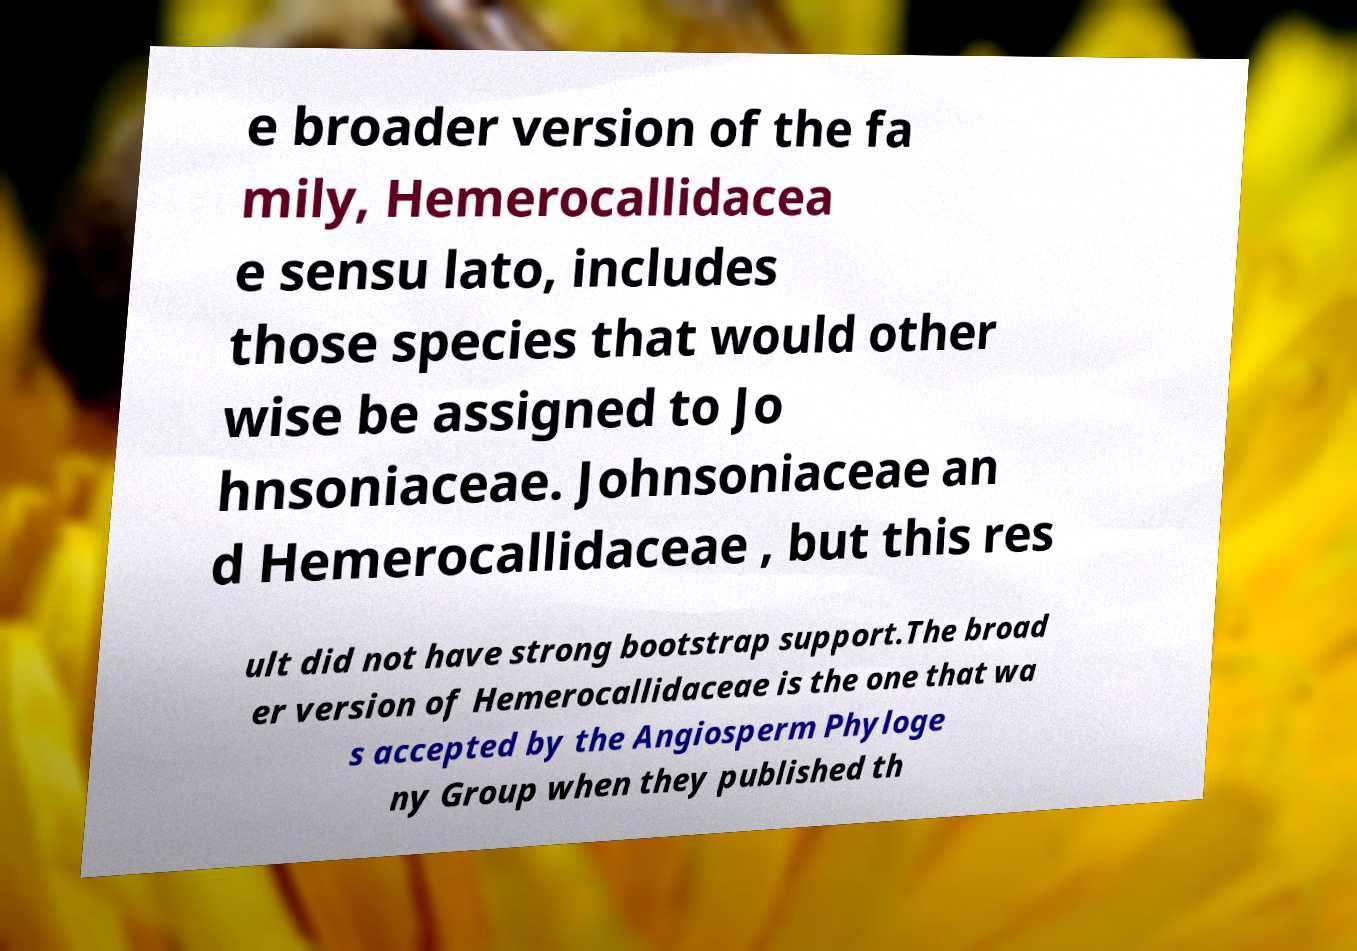Please identify and transcribe the text found in this image. e broader version of the fa mily, Hemerocallidacea e sensu lato, includes those species that would other wise be assigned to Jo hnsoniaceae. Johnsoniaceae an d Hemerocallidaceae , but this res ult did not have strong bootstrap support.The broad er version of Hemerocallidaceae is the one that wa s accepted by the Angiosperm Phyloge ny Group when they published th 